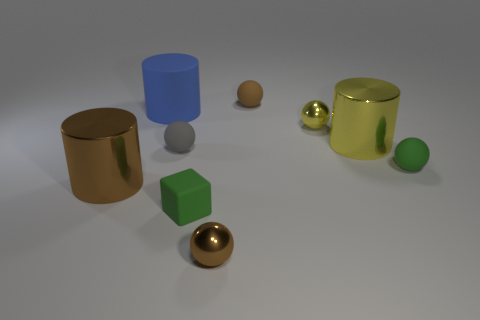Are the brown ball to the right of the small brown shiny ball and the large blue thing made of the same material?
Ensure brevity in your answer.  Yes. There is a tiny shiny thing that is behind the large yellow metallic thing; what shape is it?
Offer a terse response. Sphere. How many green balls are the same size as the blue cylinder?
Give a very brief answer. 0. What is the size of the yellow ball?
Ensure brevity in your answer.  Small. How many green matte objects are to the left of the blue matte cylinder?
Offer a terse response. 0. There is a large yellow object that is made of the same material as the yellow ball; what shape is it?
Give a very brief answer. Cylinder. Is the number of small things on the right side of the small green rubber block less than the number of metallic objects left of the tiny gray object?
Ensure brevity in your answer.  No. Is the number of small metallic cubes greater than the number of tiny gray things?
Provide a succinct answer. No. What is the material of the blue object?
Offer a very short reply. Rubber. What is the color of the small ball that is behind the tiny yellow shiny thing?
Your response must be concise. Brown. 